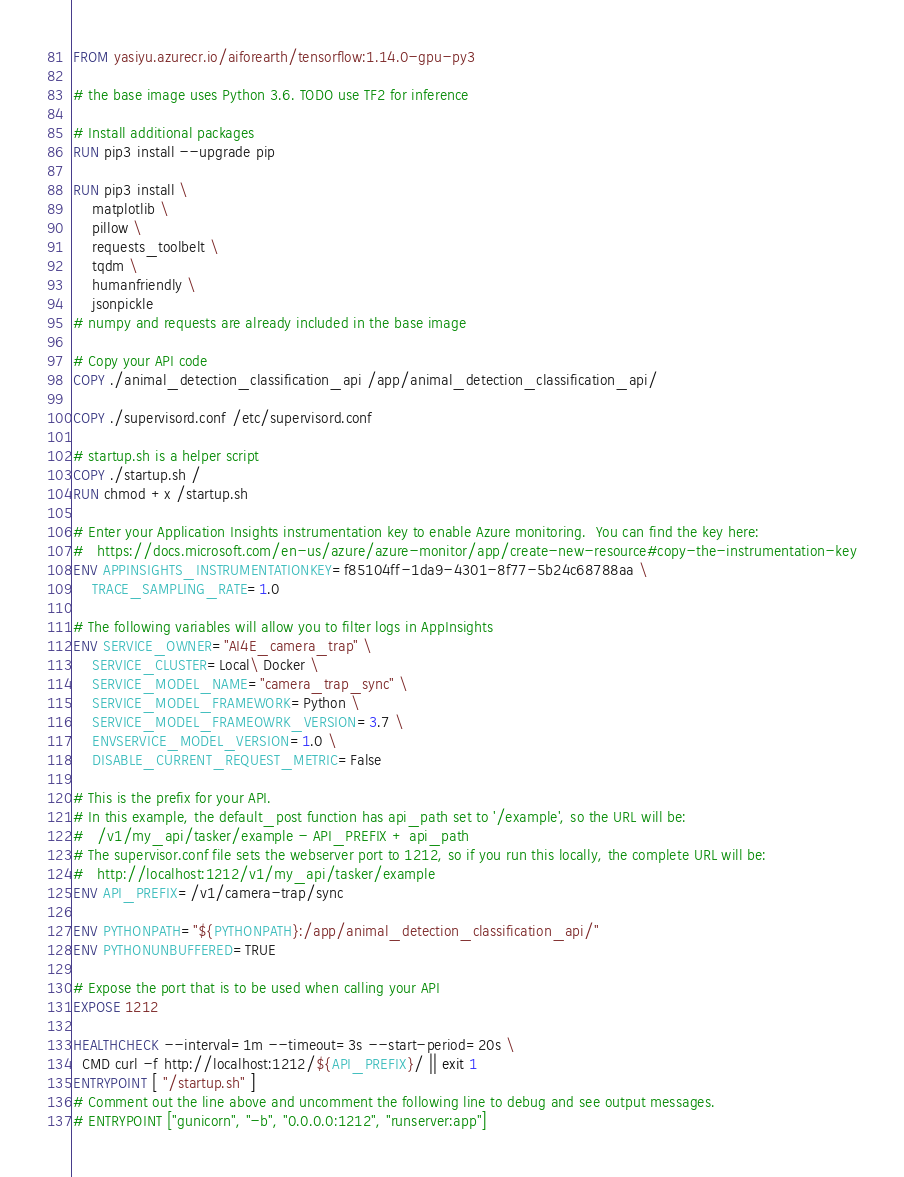<code> <loc_0><loc_0><loc_500><loc_500><_Dockerfile_>FROM yasiyu.azurecr.io/aiforearth/tensorflow:1.14.0-gpu-py3

# the base image uses Python 3.6. TODO use TF2 for inference

# Install additional packages
RUN pip3 install --upgrade pip

RUN pip3 install \
    matplotlib \
    pillow \
    requests_toolbelt \
    tqdm \
    humanfriendly \
    jsonpickle
# numpy and requests are already included in the base image

# Copy your API code
COPY ./animal_detection_classification_api /app/animal_detection_classification_api/

COPY ./supervisord.conf /etc/supervisord.conf

# startup.sh is a helper script
COPY ./startup.sh /
RUN chmod +x /startup.sh

# Enter your Application Insights instrumentation key to enable Azure monitoring.  You can find the key here:
#   https://docs.microsoft.com/en-us/azure/azure-monitor/app/create-new-resource#copy-the-instrumentation-key
ENV APPINSIGHTS_INSTRUMENTATIONKEY=f85104ff-1da9-4301-8f77-5b24c68788aa \
    TRACE_SAMPLING_RATE=1.0

# The following variables will allow you to filter logs in AppInsights
ENV SERVICE_OWNER="AI4E_camera_trap" \
    SERVICE_CLUSTER=Local\ Docker \
    SERVICE_MODEL_NAME="camera_trap_sync" \
    SERVICE_MODEL_FRAMEWORK=Python \
    SERVICE_MODEL_FRAMEOWRK_VERSION=3.7 \
    ENVSERVICE_MODEL_VERSION=1.0 \
    DISABLE_CURRENT_REQUEST_METRIC=False

# This is the prefix for your API.
# In this example, the default_post function has api_path set to '/example', so the URL will be:
#   /v1/my_api/tasker/example - API_PREFIX + api_path
# The supervisor.conf file sets the webserver port to 1212, so if you run this locally, the complete URL will be:
#   http://localhost:1212/v1/my_api/tasker/example
ENV API_PREFIX=/v1/camera-trap/sync

ENV PYTHONPATH="${PYTHONPATH}:/app/animal_detection_classification_api/"
ENV PYTHONUNBUFFERED=TRUE

# Expose the port that is to be used when calling your API
EXPOSE 1212

HEALTHCHECK --interval=1m --timeout=3s --start-period=20s \
  CMD curl -f http://localhost:1212/${API_PREFIX}/ || exit 1
ENTRYPOINT [ "/startup.sh" ]
# Comment out the line above and uncomment the following line to debug and see output messages.
# ENTRYPOINT ["gunicorn", "-b", "0.0.0.0:1212", "runserver:app"]</code> 